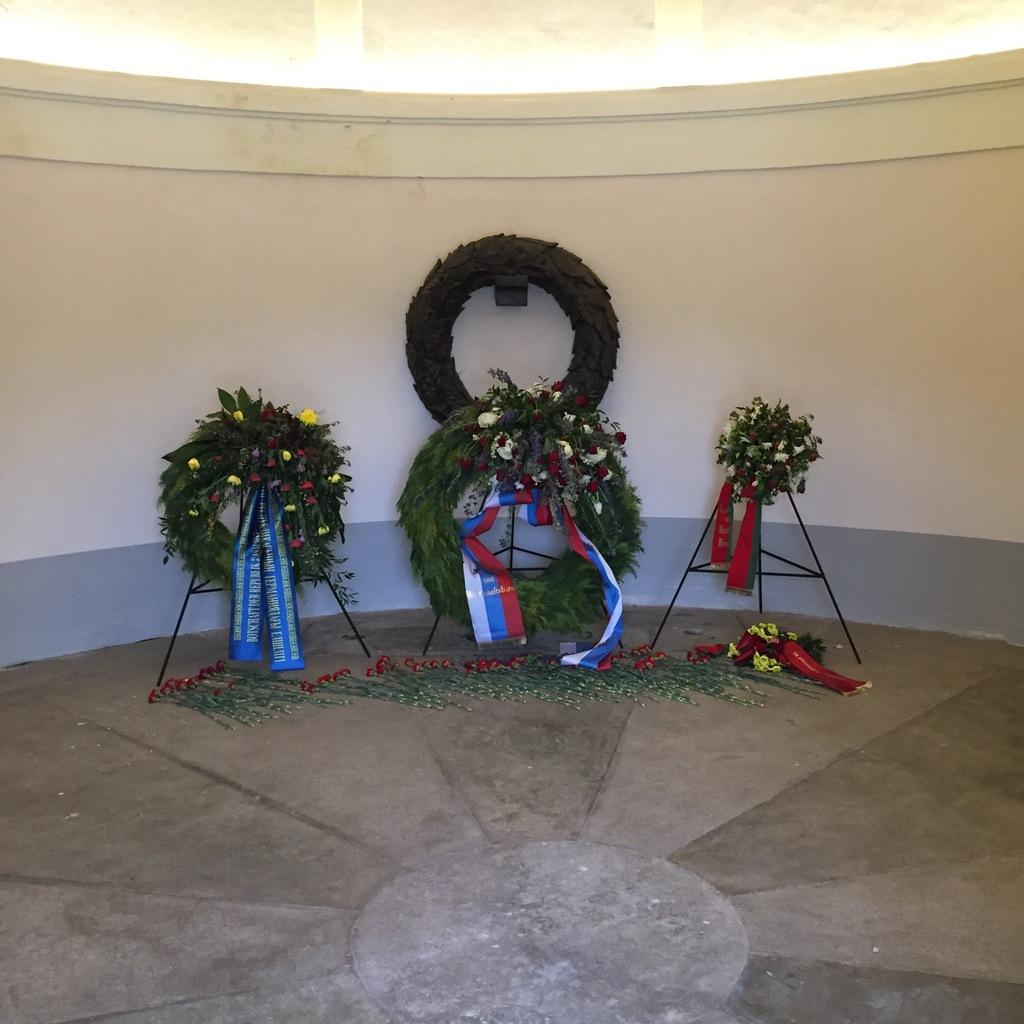What can be seen in the image that is related to flowers? There are bouquets with ribbons in the image, and there are also flowers on the floor in front of the bouquets. How are the bouquets displayed in the image? The bouquets are on stands in the image. What is visible in the background of the image? There is a wall in the background of the image. How many spiders are crawling on the bouquets in the image? There are no spiders visible in the image; it only features bouquets with ribbons and flowers on the floor. 